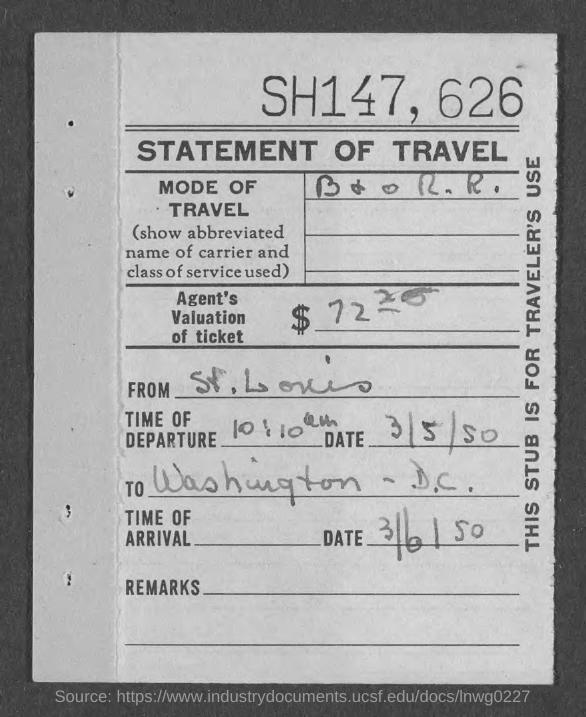Mention a couple of crucial points in this snapshot. The travel originates from St. Louis. The destination of the travel is Washington, D.C. The time of departure is 10:10 am. The top of the page contains the text 'SH147' and the numbers '626'. 